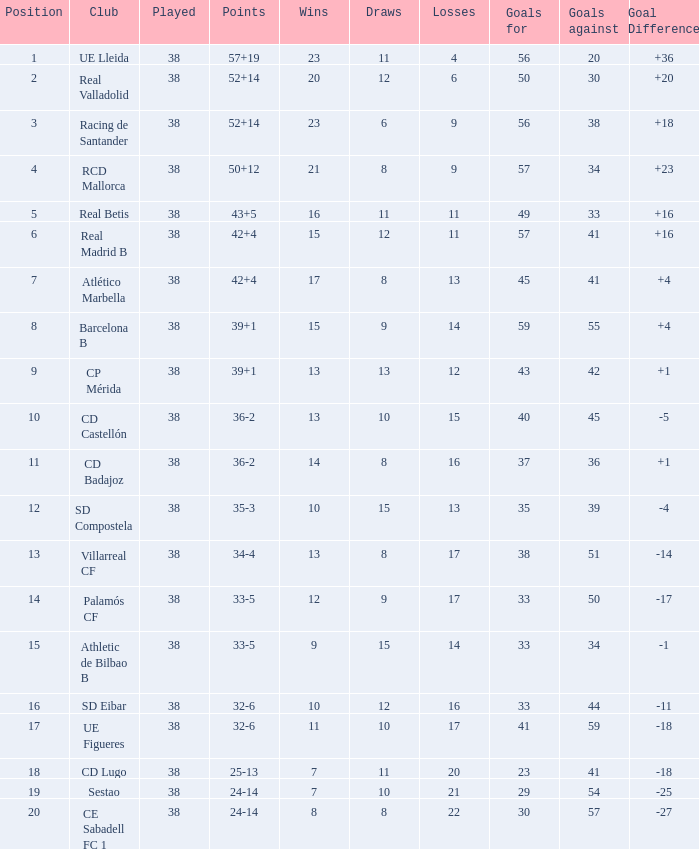What is the highest number played with a goal difference less than -27? None. 